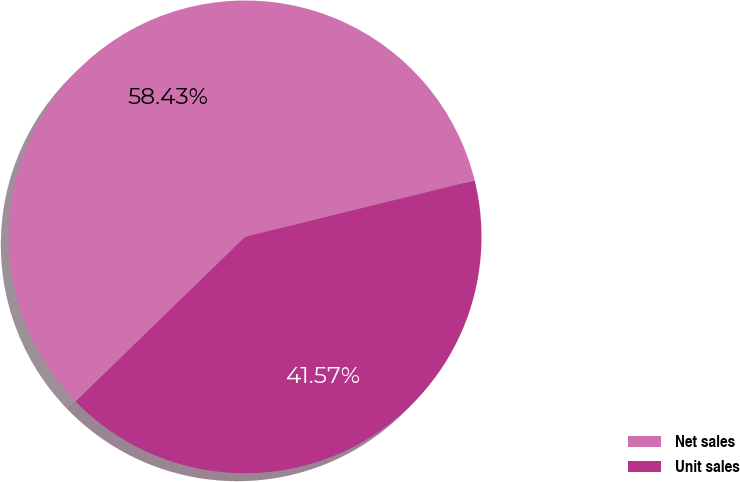Convert chart. <chart><loc_0><loc_0><loc_500><loc_500><pie_chart><fcel>Net sales<fcel>Unit sales<nl><fcel>58.43%<fcel>41.57%<nl></chart> 